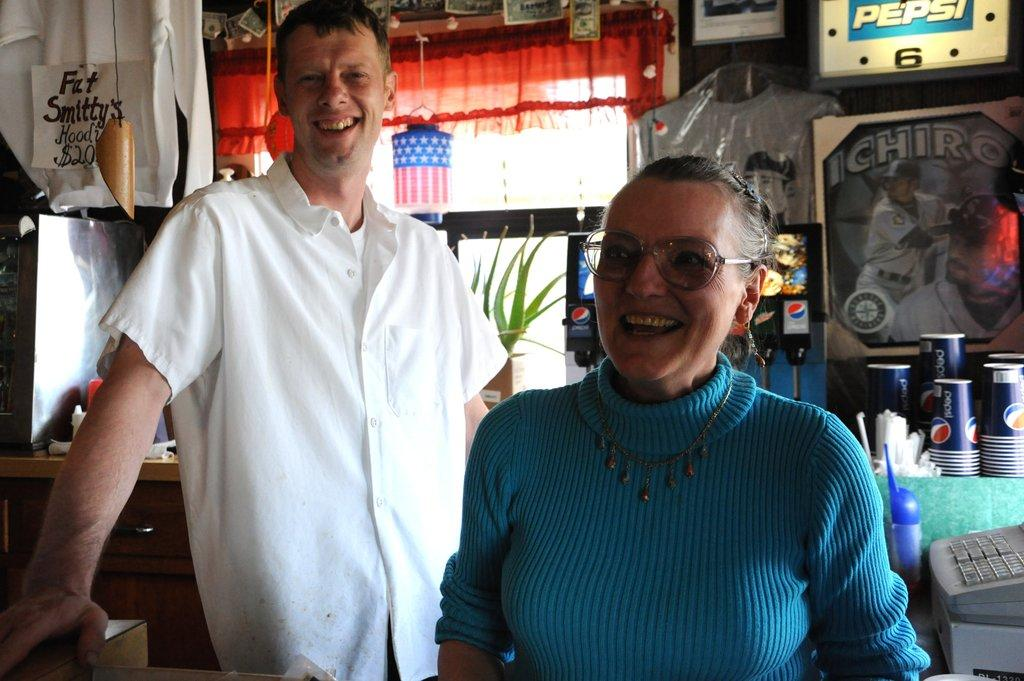How many people are in the image? There are two persons standing in the image. What is the facial expression of the persons in the image? The persons are smiling. What type of objects can be seen in the image that are typically used for drinking? There are cups visible in the image. What type of decorative items can be seen in the image? There are posters in the image. What type of objects can be seen in the image that are typically used for displaying information or announcements? There are boards in the image. What type of object can be seen in the image that is typically used for performing a specific task or function? There is a machine in the image. What type of living organism can be seen in the image? There is a plant in the image. What type of window treatment can be seen in the image? There is a curtain in the image. What type of income can be seen in the image? There is no income present in the image; it is a visual representation of people, objects, and a plant. What type of mineral can be seen in the image? There is no mineral present in the image. What type of flying object can be seen in the image? There is no kite present in the image. 